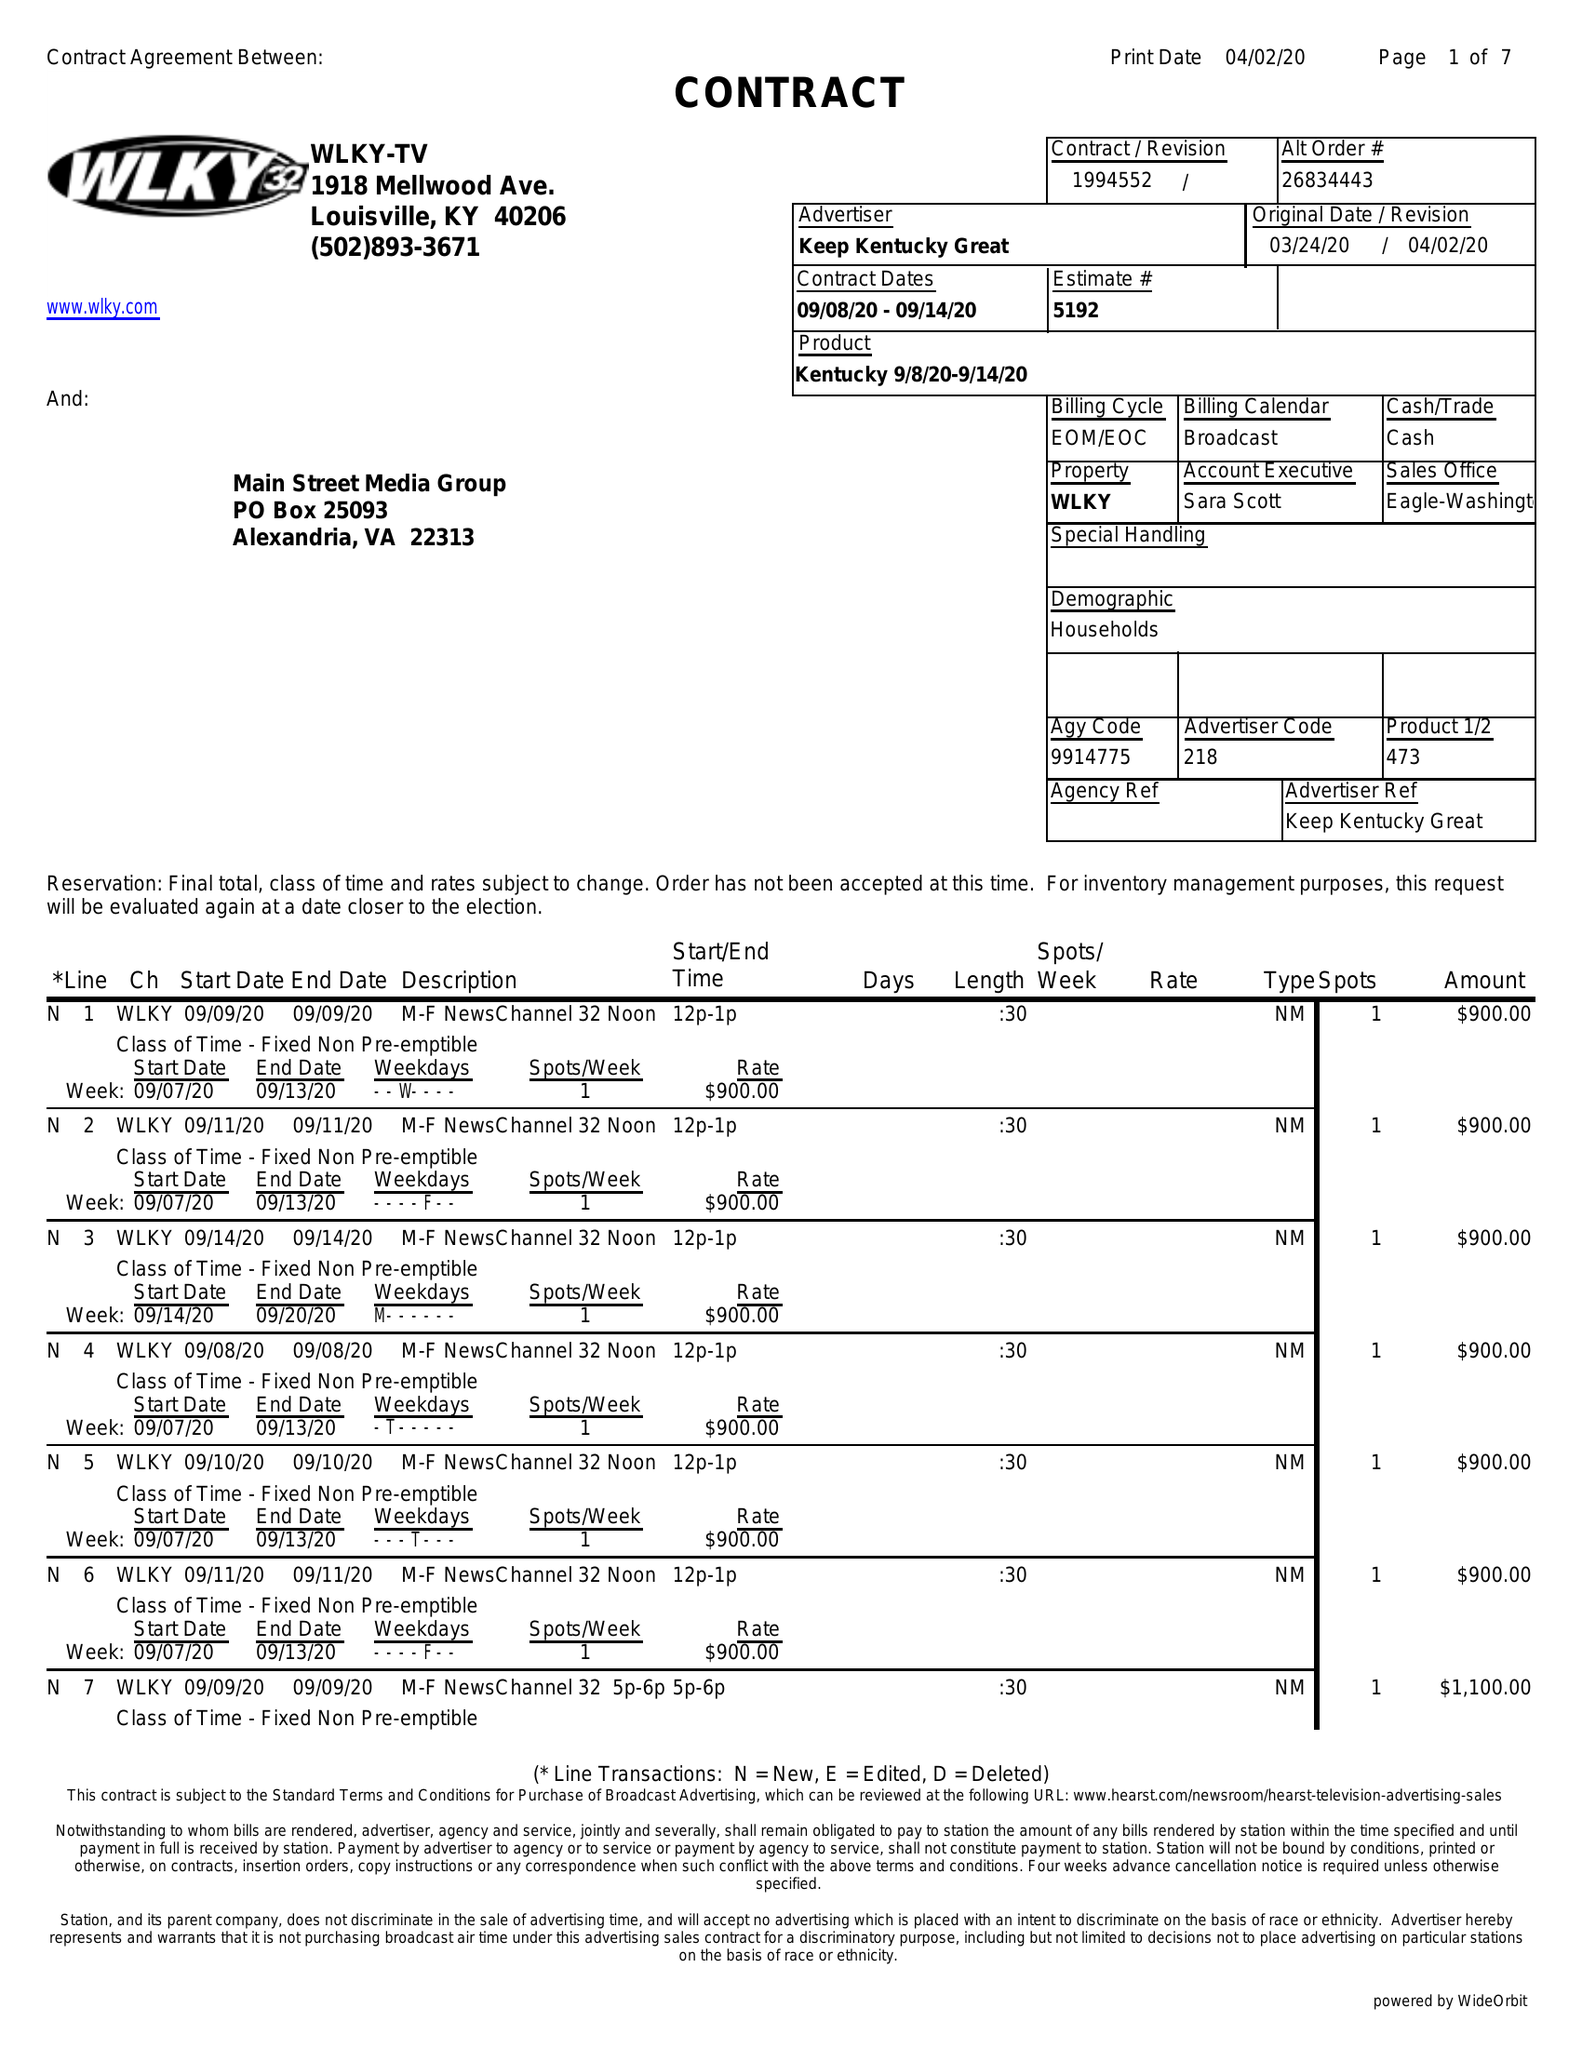What is the value for the flight_to?
Answer the question using a single word or phrase. 09/14/20 